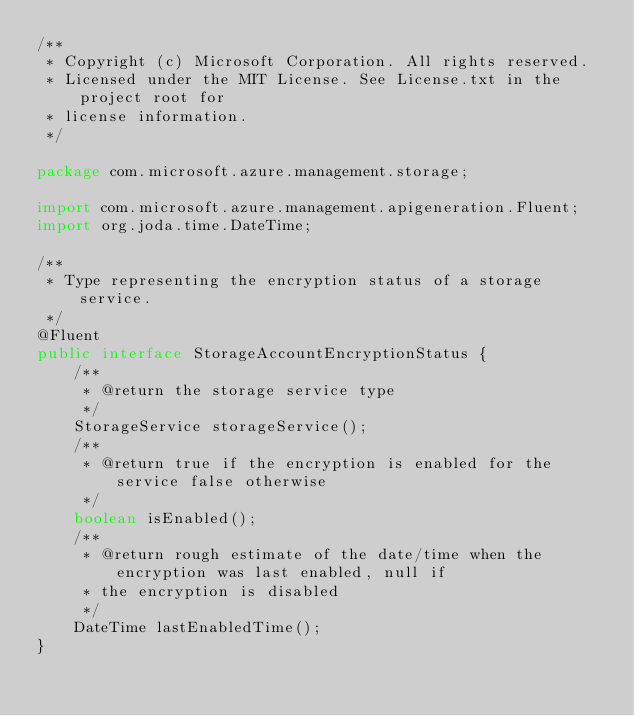Convert code to text. <code><loc_0><loc_0><loc_500><loc_500><_Java_>/**
 * Copyright (c) Microsoft Corporation. All rights reserved.
 * Licensed under the MIT License. See License.txt in the project root for
 * license information.
 */

package com.microsoft.azure.management.storage;

import com.microsoft.azure.management.apigeneration.Fluent;
import org.joda.time.DateTime;

/**
 * Type representing the encryption status of a storage service.
 */
@Fluent
public interface StorageAccountEncryptionStatus {
    /**
     * @return the storage service type
     */
    StorageService storageService();
    /**
     * @return true if the encryption is enabled for the service false otherwise
     */
    boolean isEnabled();
    /**
     * @return rough estimate of the date/time when the encryption was last enabled, null if
     * the encryption is disabled
     */
    DateTime lastEnabledTime();
}
</code> 